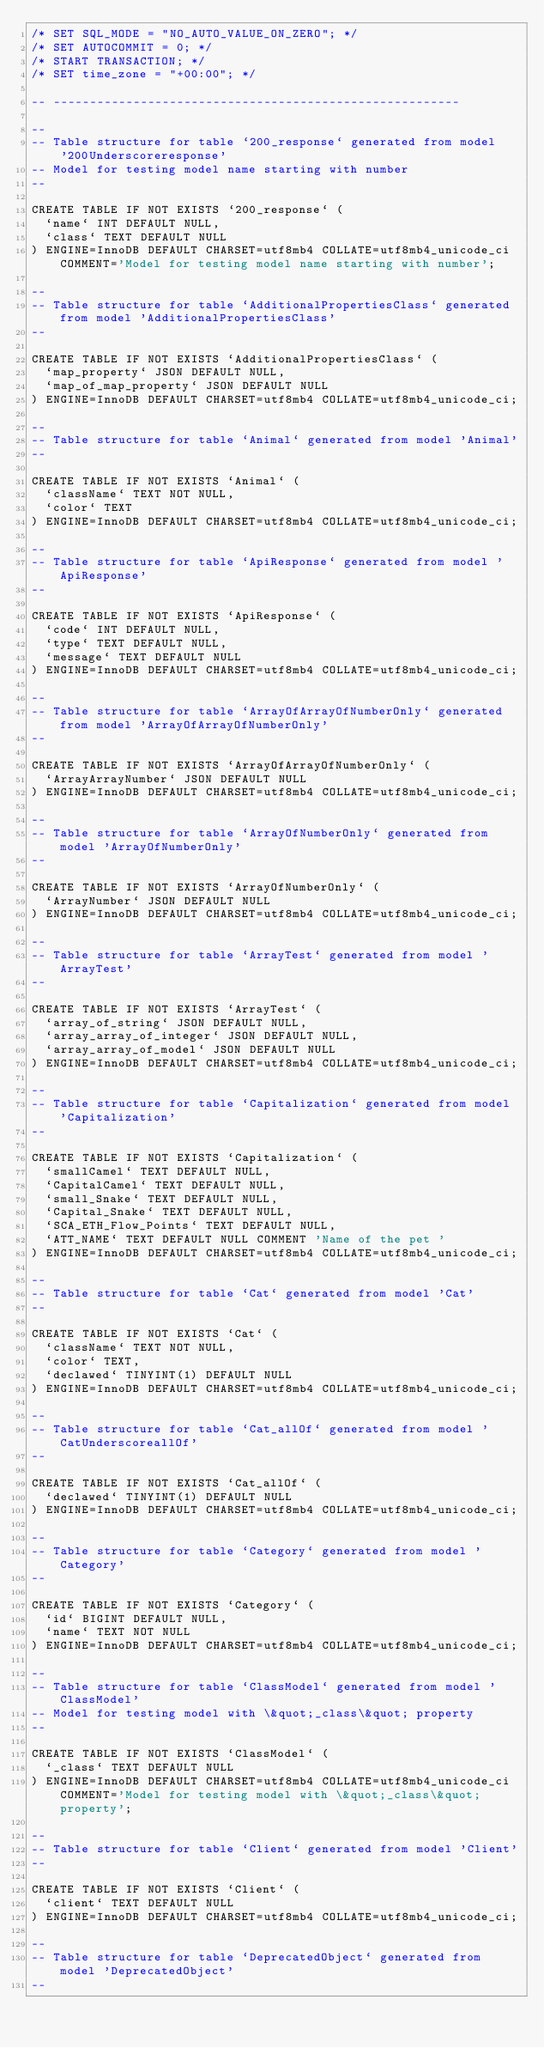<code> <loc_0><loc_0><loc_500><loc_500><_SQL_>/* SET SQL_MODE = "NO_AUTO_VALUE_ON_ZERO"; */
/* SET AUTOCOMMIT = 0; */
/* START TRANSACTION; */
/* SET time_zone = "+00:00"; */

-- --------------------------------------------------------

--
-- Table structure for table `200_response` generated from model '200Underscoreresponse'
-- Model for testing model name starting with number
--

CREATE TABLE IF NOT EXISTS `200_response` (
  `name` INT DEFAULT NULL,
  `class` TEXT DEFAULT NULL
) ENGINE=InnoDB DEFAULT CHARSET=utf8mb4 COLLATE=utf8mb4_unicode_ci COMMENT='Model for testing model name starting with number';

--
-- Table structure for table `AdditionalPropertiesClass` generated from model 'AdditionalPropertiesClass'
--

CREATE TABLE IF NOT EXISTS `AdditionalPropertiesClass` (
  `map_property` JSON DEFAULT NULL,
  `map_of_map_property` JSON DEFAULT NULL
) ENGINE=InnoDB DEFAULT CHARSET=utf8mb4 COLLATE=utf8mb4_unicode_ci;

--
-- Table structure for table `Animal` generated from model 'Animal'
--

CREATE TABLE IF NOT EXISTS `Animal` (
  `className` TEXT NOT NULL,
  `color` TEXT
) ENGINE=InnoDB DEFAULT CHARSET=utf8mb4 COLLATE=utf8mb4_unicode_ci;

--
-- Table structure for table `ApiResponse` generated from model 'ApiResponse'
--

CREATE TABLE IF NOT EXISTS `ApiResponse` (
  `code` INT DEFAULT NULL,
  `type` TEXT DEFAULT NULL,
  `message` TEXT DEFAULT NULL
) ENGINE=InnoDB DEFAULT CHARSET=utf8mb4 COLLATE=utf8mb4_unicode_ci;

--
-- Table structure for table `ArrayOfArrayOfNumberOnly` generated from model 'ArrayOfArrayOfNumberOnly'
--

CREATE TABLE IF NOT EXISTS `ArrayOfArrayOfNumberOnly` (
  `ArrayArrayNumber` JSON DEFAULT NULL
) ENGINE=InnoDB DEFAULT CHARSET=utf8mb4 COLLATE=utf8mb4_unicode_ci;

--
-- Table structure for table `ArrayOfNumberOnly` generated from model 'ArrayOfNumberOnly'
--

CREATE TABLE IF NOT EXISTS `ArrayOfNumberOnly` (
  `ArrayNumber` JSON DEFAULT NULL
) ENGINE=InnoDB DEFAULT CHARSET=utf8mb4 COLLATE=utf8mb4_unicode_ci;

--
-- Table structure for table `ArrayTest` generated from model 'ArrayTest'
--

CREATE TABLE IF NOT EXISTS `ArrayTest` (
  `array_of_string` JSON DEFAULT NULL,
  `array_array_of_integer` JSON DEFAULT NULL,
  `array_array_of_model` JSON DEFAULT NULL
) ENGINE=InnoDB DEFAULT CHARSET=utf8mb4 COLLATE=utf8mb4_unicode_ci;

--
-- Table structure for table `Capitalization` generated from model 'Capitalization'
--

CREATE TABLE IF NOT EXISTS `Capitalization` (
  `smallCamel` TEXT DEFAULT NULL,
  `CapitalCamel` TEXT DEFAULT NULL,
  `small_Snake` TEXT DEFAULT NULL,
  `Capital_Snake` TEXT DEFAULT NULL,
  `SCA_ETH_Flow_Points` TEXT DEFAULT NULL,
  `ATT_NAME` TEXT DEFAULT NULL COMMENT 'Name of the pet '
) ENGINE=InnoDB DEFAULT CHARSET=utf8mb4 COLLATE=utf8mb4_unicode_ci;

--
-- Table structure for table `Cat` generated from model 'Cat'
--

CREATE TABLE IF NOT EXISTS `Cat` (
  `className` TEXT NOT NULL,
  `color` TEXT,
  `declawed` TINYINT(1) DEFAULT NULL
) ENGINE=InnoDB DEFAULT CHARSET=utf8mb4 COLLATE=utf8mb4_unicode_ci;

--
-- Table structure for table `Cat_allOf` generated from model 'CatUnderscoreallOf'
--

CREATE TABLE IF NOT EXISTS `Cat_allOf` (
  `declawed` TINYINT(1) DEFAULT NULL
) ENGINE=InnoDB DEFAULT CHARSET=utf8mb4 COLLATE=utf8mb4_unicode_ci;

--
-- Table structure for table `Category` generated from model 'Category'
--

CREATE TABLE IF NOT EXISTS `Category` (
  `id` BIGINT DEFAULT NULL,
  `name` TEXT NOT NULL
) ENGINE=InnoDB DEFAULT CHARSET=utf8mb4 COLLATE=utf8mb4_unicode_ci;

--
-- Table structure for table `ClassModel` generated from model 'ClassModel'
-- Model for testing model with \&quot;_class\&quot; property
--

CREATE TABLE IF NOT EXISTS `ClassModel` (
  `_class` TEXT DEFAULT NULL
) ENGINE=InnoDB DEFAULT CHARSET=utf8mb4 COLLATE=utf8mb4_unicode_ci COMMENT='Model for testing model with \&quot;_class\&quot; property';

--
-- Table structure for table `Client` generated from model 'Client'
--

CREATE TABLE IF NOT EXISTS `Client` (
  `client` TEXT DEFAULT NULL
) ENGINE=InnoDB DEFAULT CHARSET=utf8mb4 COLLATE=utf8mb4_unicode_ci;

--
-- Table structure for table `DeprecatedObject` generated from model 'DeprecatedObject'
--
</code> 